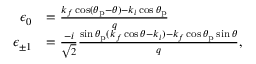<formula> <loc_0><loc_0><loc_500><loc_500>\begin{array} { r l } { \epsilon _ { 0 } } & { = \frac { k _ { f } \cos ( \theta _ { p } - \theta ) - k _ { i } \cos \theta _ { p } } { q } } \\ { \epsilon _ { \pm 1 } } & { = \frac { - i } { \sqrt { 2 } } \frac { \sin \theta _ { p } ( k _ { f } \cos \theta - k _ { i } ) - k _ { f } \cos \theta _ { p } \sin \theta } { q } , } \end{array}</formula> 